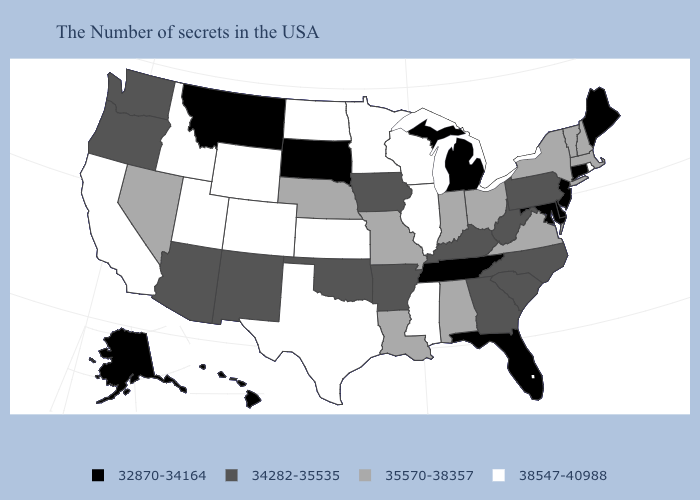What is the value of Arkansas?
Keep it brief. 34282-35535. What is the value of Kentucky?
Short answer required. 34282-35535. What is the lowest value in the USA?
Give a very brief answer. 32870-34164. Which states hav the highest value in the West?
Write a very short answer. Wyoming, Colorado, Utah, Idaho, California. Name the states that have a value in the range 35570-38357?
Be succinct. Massachusetts, New Hampshire, Vermont, New York, Virginia, Ohio, Indiana, Alabama, Louisiana, Missouri, Nebraska, Nevada. Name the states that have a value in the range 32870-34164?
Concise answer only. Maine, Connecticut, New Jersey, Delaware, Maryland, Florida, Michigan, Tennessee, South Dakota, Montana, Alaska, Hawaii. Which states hav the highest value in the MidWest?
Answer briefly. Wisconsin, Illinois, Minnesota, Kansas, North Dakota. Which states have the lowest value in the South?
Be succinct. Delaware, Maryland, Florida, Tennessee. Among the states that border Nebraska , does Wyoming have the highest value?
Concise answer only. Yes. Name the states that have a value in the range 38547-40988?
Give a very brief answer. Rhode Island, Wisconsin, Illinois, Mississippi, Minnesota, Kansas, Texas, North Dakota, Wyoming, Colorado, Utah, Idaho, California. Name the states that have a value in the range 38547-40988?
Quick response, please. Rhode Island, Wisconsin, Illinois, Mississippi, Minnesota, Kansas, Texas, North Dakota, Wyoming, Colorado, Utah, Idaho, California. Does Montana have the same value as Maryland?
Concise answer only. Yes. Which states have the highest value in the USA?
Be succinct. Rhode Island, Wisconsin, Illinois, Mississippi, Minnesota, Kansas, Texas, North Dakota, Wyoming, Colorado, Utah, Idaho, California. What is the highest value in the USA?
Concise answer only. 38547-40988. What is the lowest value in the USA?
Be succinct. 32870-34164. 